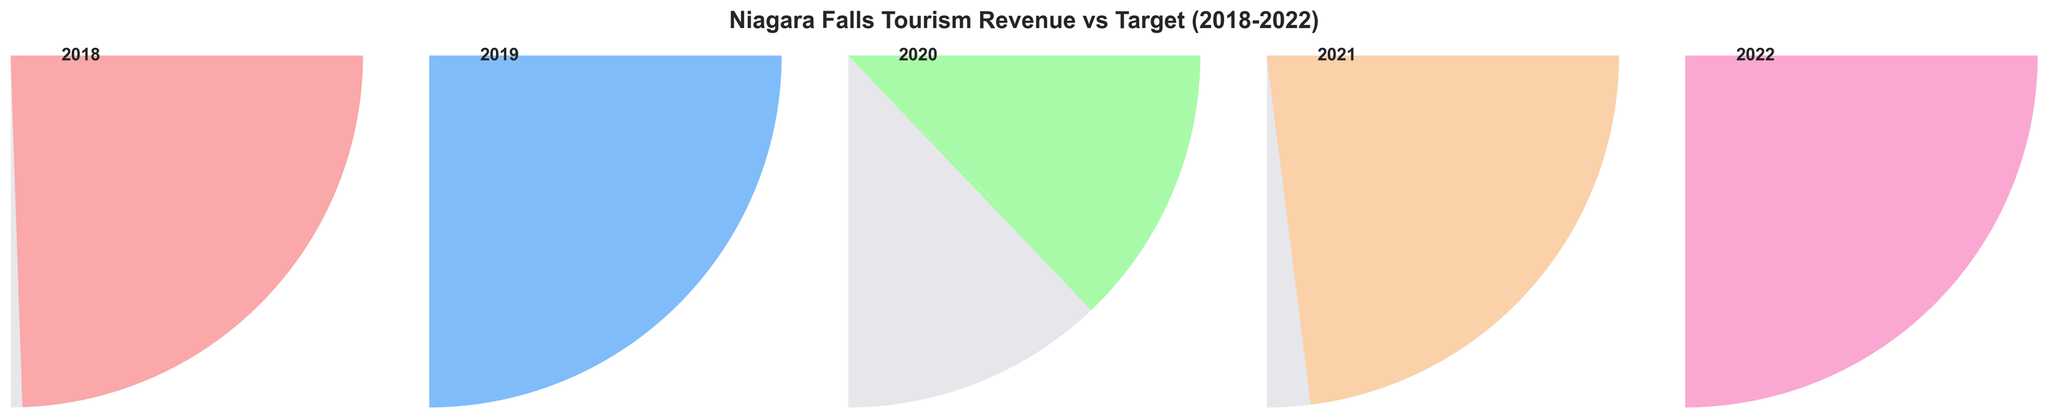What is the title of the figure? The title is displayed at the top of the figure, prominently in bold text.
Answer: Niagara Falls Tourism Revenue vs Target (2018-2022) Which year had the lowest percentage of the target revenue achieved? By comparing the text values provided in the gauge charts for each year, 2020 shows the lowest at 51.5%. This is calculated by $(412 / 800) * 100 \approx 51.5\%$.
Answer: 2020 In which year did the actual revenue surpass the target revenue? By observing the percentages and comparing the actual revenue against the target, 2019 had an actual revenue of $778M, which is higher than the target of $750M. This is also reflected in the gauge showing 103.7%.
Answer: 2019 How did the actual revenue in 2020 compare to the target for 2020? In 2020, the actual revenue was $412M, and the target was $800M. To calculate: $(412 / 800) * 100 = 51.5\%$, showing the actual revenue fell short of the target.
Answer: 758M What percentage of the target revenue did Niagara Falls achieve in 2022? The gauge chart for 2022 indicates the value by presenting text inside the gauge. It is (732 / 700) * 100 = 104.6%. This can be seen directly within the chart.
Answer: 104.6% Which year had the highest actual revenue? By comparing the actual revenue values displayed for each year, 2019 had the highest actual revenue of $778M.
Answer: 2019 What is the average percentage of target revenue achieved over the five years? First, sum up the percentages achieved in each gauge chart, then divide by 5. So, $(97.9 + 103.7 + 51.5 + 93.1 + 104.6) / 5 = 90.2\%$.
Answer: 90.2% Compare the actual revenue of 2018 and 2021. Which was higher and by how much? The actual revenue in 2018 was $685M, and in 2021 it was $598M. The difference is $685M - $598M = $87M. 2018 had a higher actual revenue than 2021 by $87M.
Answer: 2018, $87M How does the color used in the 2020 gauge chart differ from the others? Each gauge uses a distinct color to differentiate between the years. The specific color for 2020 is unique and can be identified as different from the others by close observation.
Answer: It is uniquely assigned a different color What is the median actual revenue from 2018 to 2022? Sort the actual revenue values: $412M, $598M, $685M, $732M, $778M$. The middle value is the median.
Answer: $685M 